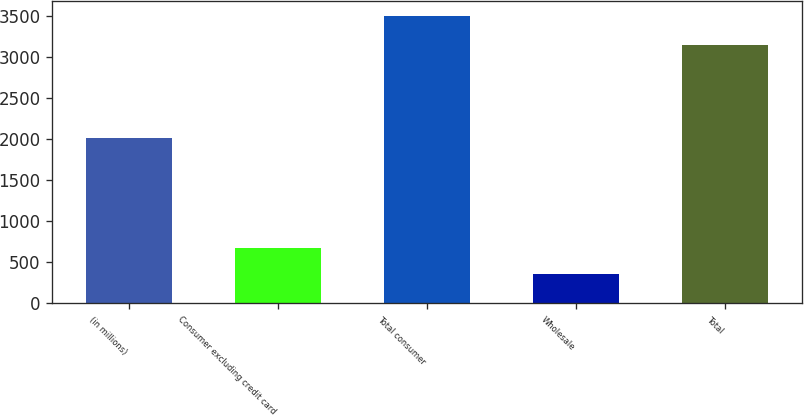Convert chart to OTSL. <chart><loc_0><loc_0><loc_500><loc_500><bar_chart><fcel>(in millions)<fcel>Consumer excluding credit card<fcel>Total consumer<fcel>Wholesale<fcel>Total<nl><fcel>2014<fcel>672.9<fcel>3498<fcel>359<fcel>3139<nl></chart> 